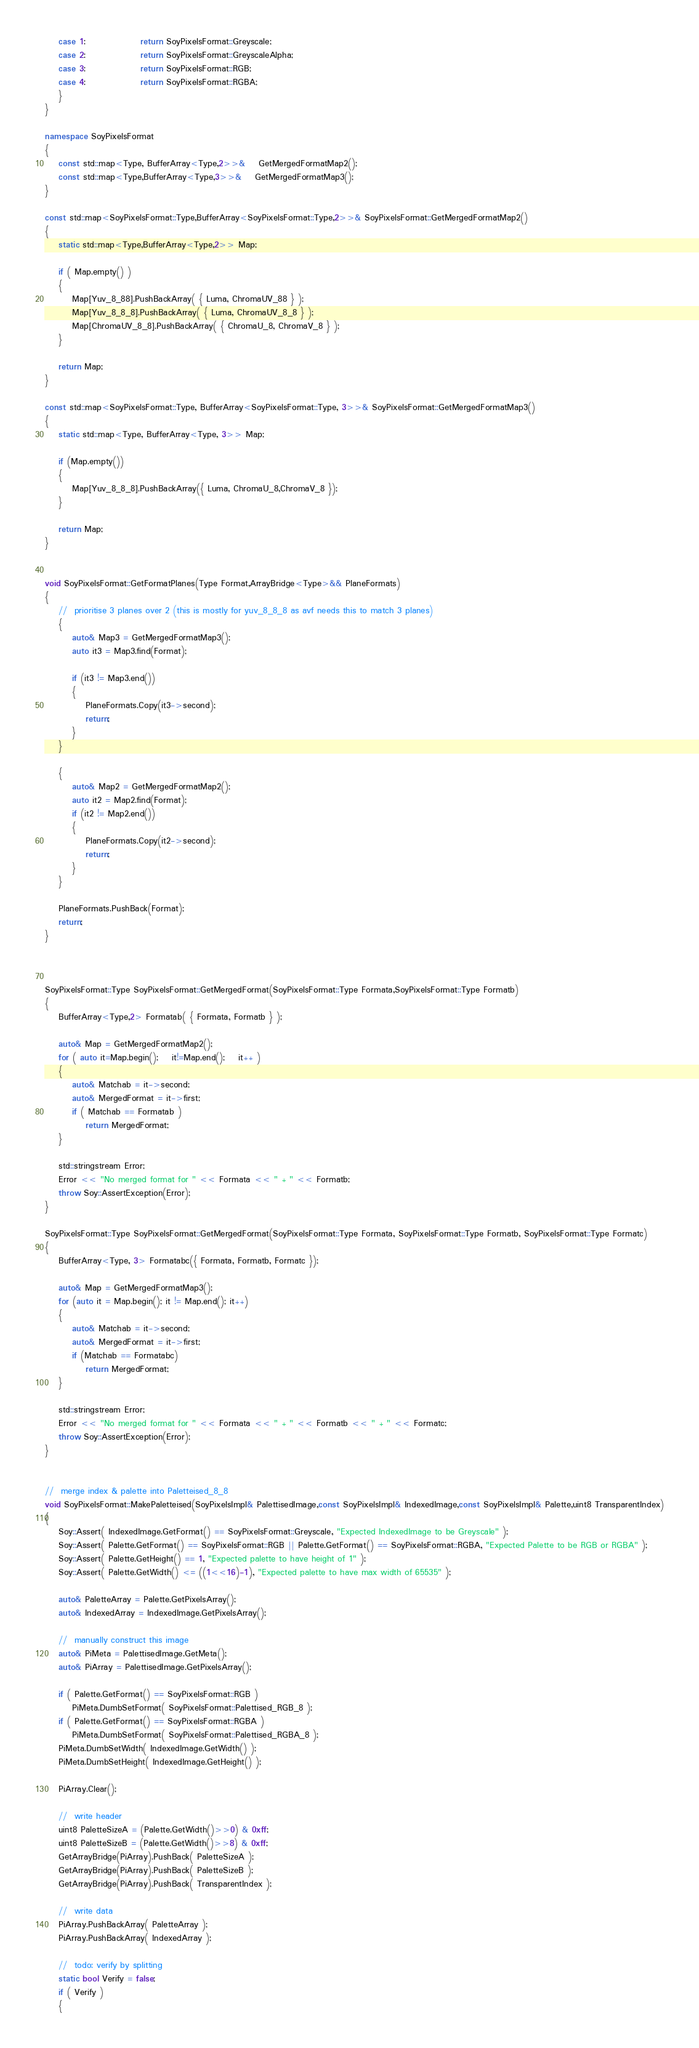<code> <loc_0><loc_0><loc_500><loc_500><_C++_>	case 1:				return SoyPixelsFormat::Greyscale;
	case 2:				return SoyPixelsFormat::GreyscaleAlpha;
	case 3:				return SoyPixelsFormat::RGB;
	case 4:				return SoyPixelsFormat::RGBA;
	}
}

namespace SoyPixelsFormat
{
	const std::map<Type, BufferArray<Type,2>>&	GetMergedFormatMap2();
	const std::map<Type,BufferArray<Type,3>>&	GetMergedFormatMap3();
}

const std::map<SoyPixelsFormat::Type,BufferArray<SoyPixelsFormat::Type,2>>& SoyPixelsFormat::GetMergedFormatMap2()
{
	static std::map<Type,BufferArray<Type,2>> Map;

	if ( Map.empty() )
	{
		Map[Yuv_8_88].PushBackArray( { Luma, ChromaUV_88 } );
		Map[Yuv_8_8_8].PushBackArray( { Luma, ChromaUV_8_8 } );
		Map[ChromaUV_8_8].PushBackArray( { ChromaU_8, ChromaV_8 } );
	}

	return Map;
}

const std::map<SoyPixelsFormat::Type, BufferArray<SoyPixelsFormat::Type, 3>>& SoyPixelsFormat::GetMergedFormatMap3()
{
	static std::map<Type, BufferArray<Type, 3>> Map;

	if (Map.empty())
	{
		Map[Yuv_8_8_8].PushBackArray({ Luma, ChromaU_8,ChromaV_8 });
	}

	return Map;
}


void SoyPixelsFormat::GetFormatPlanes(Type Format,ArrayBridge<Type>&& PlaneFormats)
{
	//	prioritise 3 planes over 2 (this is mostly for yuv_8_8_8 as avf needs this to match 3 planes)
	{
		auto& Map3 = GetMergedFormatMap3();
		auto it3 = Map3.find(Format);
		
		if (it3 != Map3.end())
		{
			PlaneFormats.Copy(it3->second);
			return;
		}
	}

	{
		auto& Map2 = GetMergedFormatMap2();
		auto it2 = Map2.find(Format);
		if (it2 != Map2.end())
		{
			PlaneFormats.Copy(it2->second);
			return;
		}
	}

	PlaneFormats.PushBack(Format);
	return;
}



SoyPixelsFormat::Type SoyPixelsFormat::GetMergedFormat(SoyPixelsFormat::Type Formata,SoyPixelsFormat::Type Formatb)
{
	BufferArray<Type,2> Formatab( { Formata, Formatb } );

	auto& Map = GetMergedFormatMap2();
	for ( auto it=Map.begin();	it!=Map.end();	it++ )
	{
		auto& Matchab = it->second;
		auto& MergedFormat = it->first;
		if ( Matchab == Formatab )
			return MergedFormat;
	}

	std::stringstream Error;
	Error << "No merged format for " << Formata << " + " << Formatb;
	throw Soy::AssertException(Error);
}

SoyPixelsFormat::Type SoyPixelsFormat::GetMergedFormat(SoyPixelsFormat::Type Formata, SoyPixelsFormat::Type Formatb, SoyPixelsFormat::Type Formatc)
{
	BufferArray<Type, 3> Formatabc({ Formata, Formatb, Formatc });

	auto& Map = GetMergedFormatMap3();
	for (auto it = Map.begin(); it != Map.end(); it++)
	{
		auto& Matchab = it->second;
		auto& MergedFormat = it->first;
		if (Matchab == Formatabc)
			return MergedFormat;
	}

	std::stringstream Error;
	Error << "No merged format for " << Formata << " + " << Formatb << " + " << Formatc;
	throw Soy::AssertException(Error);
}


//	merge index & palette into Paletteised_8_8
void SoyPixelsFormat::MakePaletteised(SoyPixelsImpl& PalettisedImage,const SoyPixelsImpl& IndexedImage,const SoyPixelsImpl& Palette,uint8 TransparentIndex)
{
	Soy::Assert( IndexedImage.GetFormat() == SoyPixelsFormat::Greyscale, "Expected IndexedImage to be Greyscale" );
	Soy::Assert( Palette.GetFormat() == SoyPixelsFormat::RGB || Palette.GetFormat() == SoyPixelsFormat::RGBA, "Expected Palette to be RGB or RGBA" );
	Soy::Assert( Palette.GetHeight() == 1, "Expected palette to have height of 1" );
	Soy::Assert( Palette.GetWidth() <= ((1<<16)-1), "Expected palette to have max width of 65535" );

	auto& PaletteArray = Palette.GetPixelsArray();
	auto& IndexedArray = IndexedImage.GetPixelsArray();
	
	//	manually construct this image
	auto& PiMeta = PalettisedImage.GetMeta();
	auto& PiArray = PalettisedImage.GetPixelsArray();

	if ( Palette.GetFormat() == SoyPixelsFormat::RGB )
		PiMeta.DumbSetFormat( SoyPixelsFormat::Palettised_RGB_8 );
	if ( Palette.GetFormat() == SoyPixelsFormat::RGBA )
		PiMeta.DumbSetFormat( SoyPixelsFormat::Palettised_RGBA_8 );
	PiMeta.DumbSetWidth( IndexedImage.GetWidth() );
	PiMeta.DumbSetHeight( IndexedImage.GetHeight() );

	PiArray.Clear();
	
	//	write header
	uint8 PaletteSizeA = (Palette.GetWidth()>>0) & 0xff;
	uint8 PaletteSizeB = (Palette.GetWidth()>>8) & 0xff;
	GetArrayBridge(PiArray).PushBack( PaletteSizeA );
	GetArrayBridge(PiArray).PushBack( PaletteSizeB );
	GetArrayBridge(PiArray).PushBack( TransparentIndex );

	//	write data
	PiArray.PushBackArray( PaletteArray );
	PiArray.PushBackArray( IndexedArray );
	
	//	todo: verify by splitting
	static bool Verify = false;
	if ( Verify )
	{</code> 